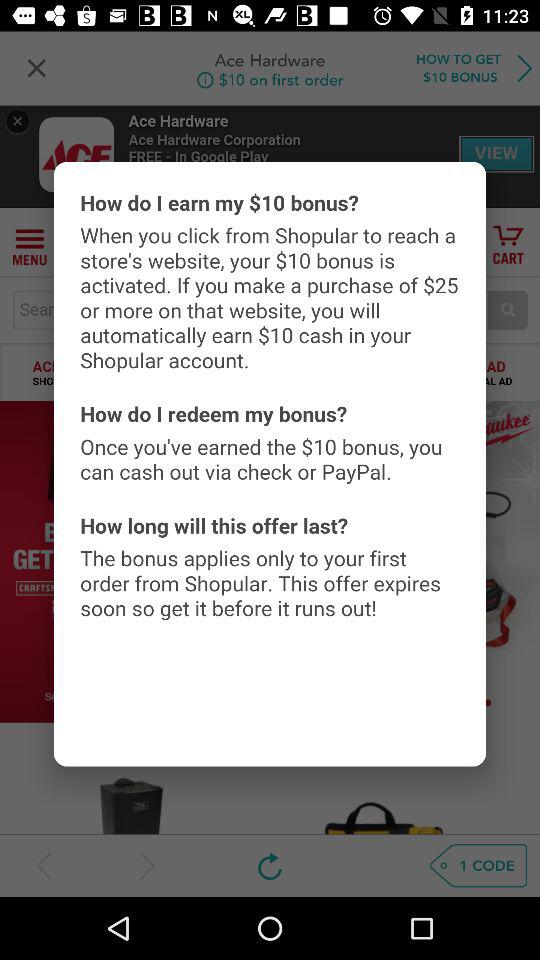How much is the bonus amount activated from the "Shopular"? The bonus amount activated is $10. 